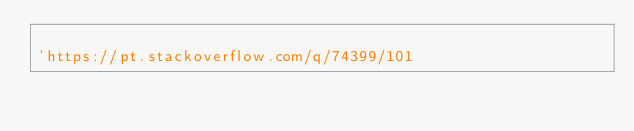Convert code to text. <code><loc_0><loc_0><loc_500><loc_500><_VisualBasic_>
'https://pt.stackoverflow.com/q/74399/101
</code> 